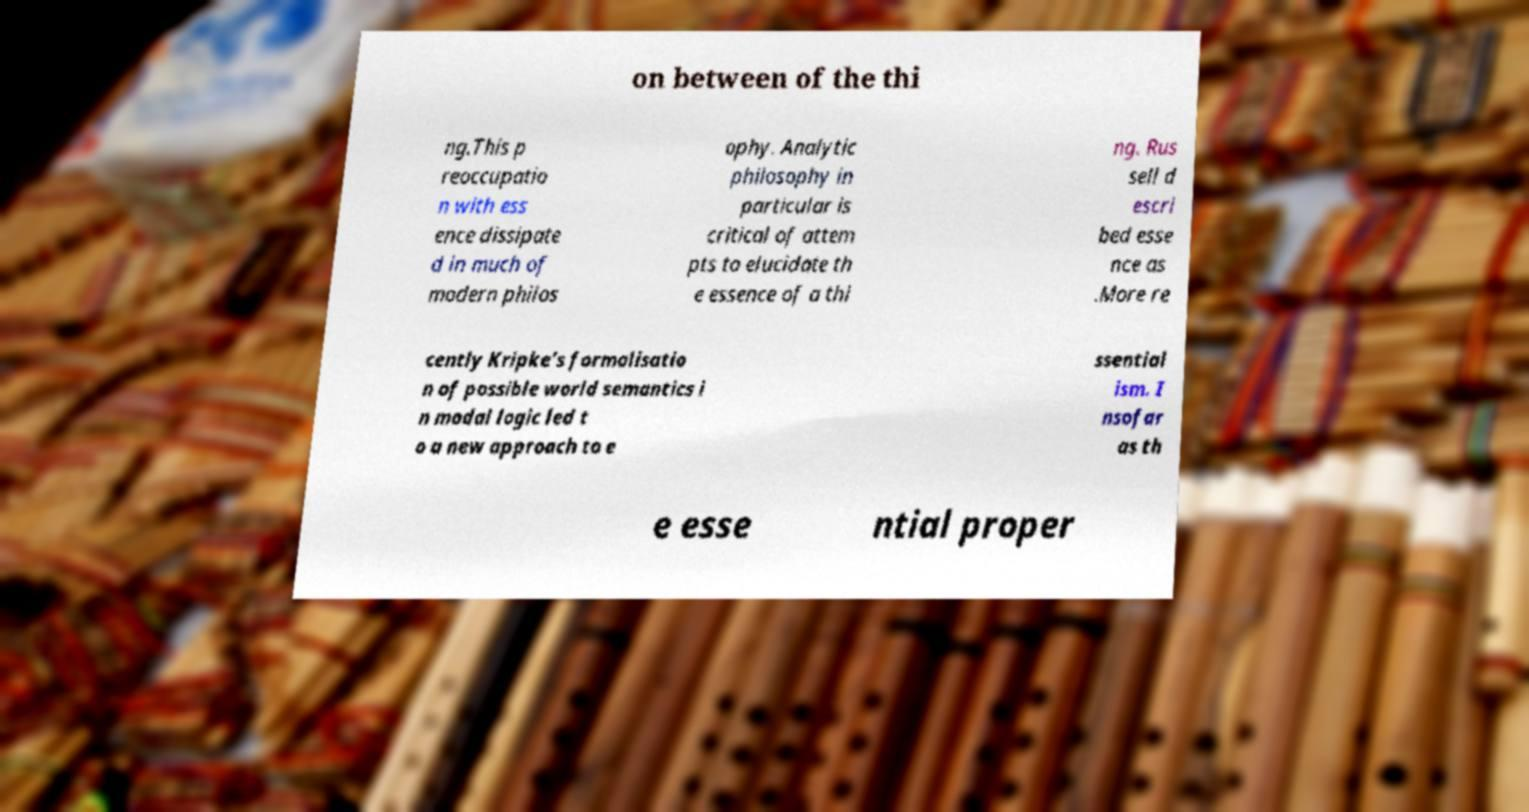There's text embedded in this image that I need extracted. Can you transcribe it verbatim? on between of the thi ng.This p reoccupatio n with ess ence dissipate d in much of modern philos ophy. Analytic philosophy in particular is critical of attem pts to elucidate th e essence of a thi ng. Rus sell d escri bed esse nce as .More re cently Kripke's formalisatio n of possible world semantics i n modal logic led t o a new approach to e ssential ism. I nsofar as th e esse ntial proper 